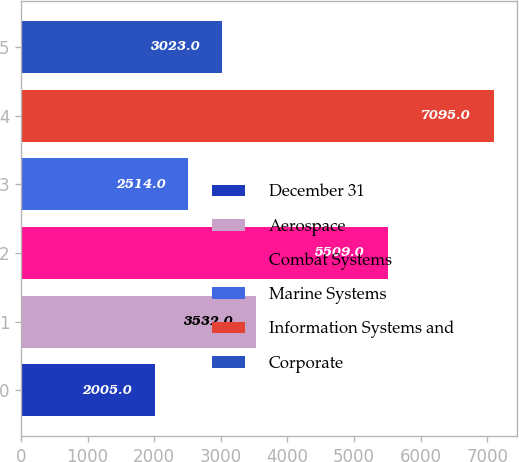Convert chart to OTSL. <chart><loc_0><loc_0><loc_500><loc_500><bar_chart><fcel>December 31<fcel>Aerospace<fcel>Combat Systems<fcel>Marine Systems<fcel>Information Systems and<fcel>Corporate<nl><fcel>2005<fcel>3532<fcel>5509<fcel>2514<fcel>7095<fcel>3023<nl></chart> 